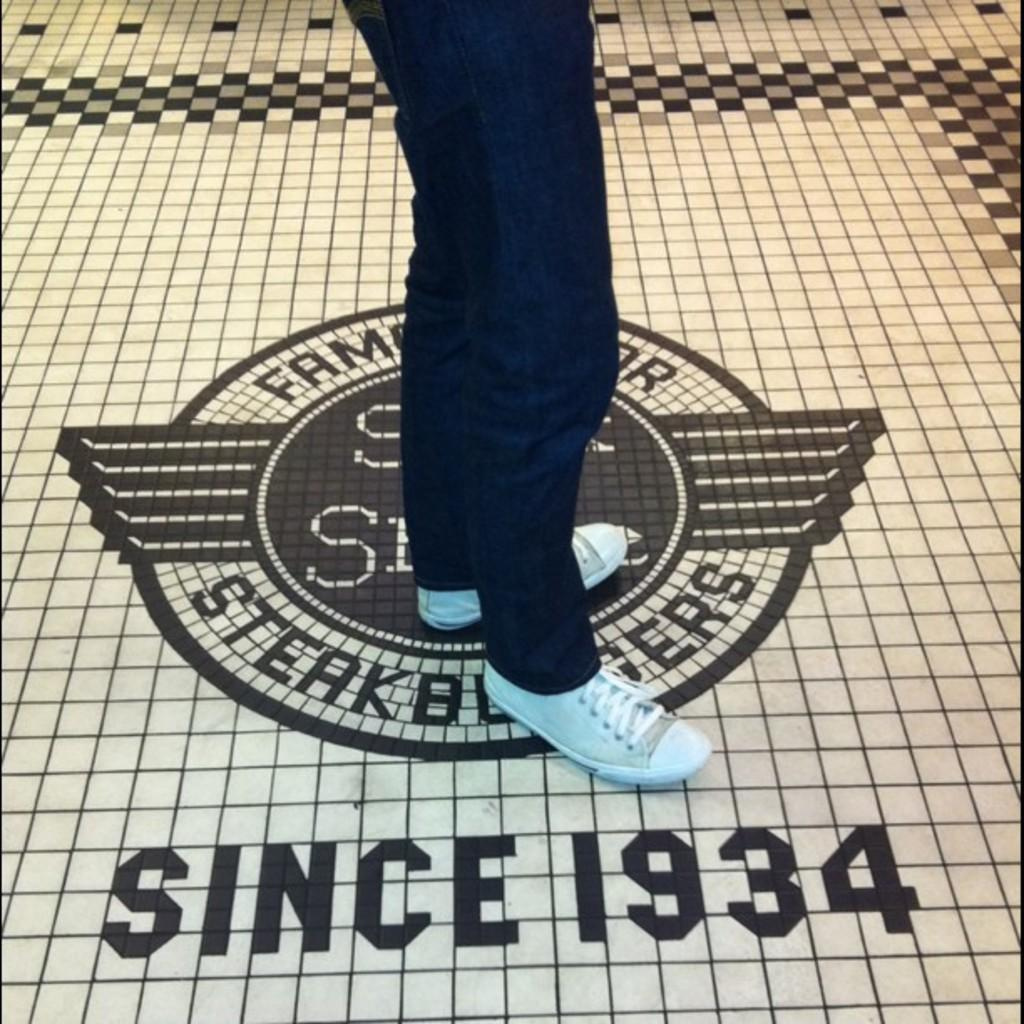What is the primary subject in the image? There is a person in the image. Can you describe the person's position in the image? The person is standing on the floor. What type of bone can be seen in the person's hand in the image? There is no bone present in the image; the person is simply standing on the floor. 